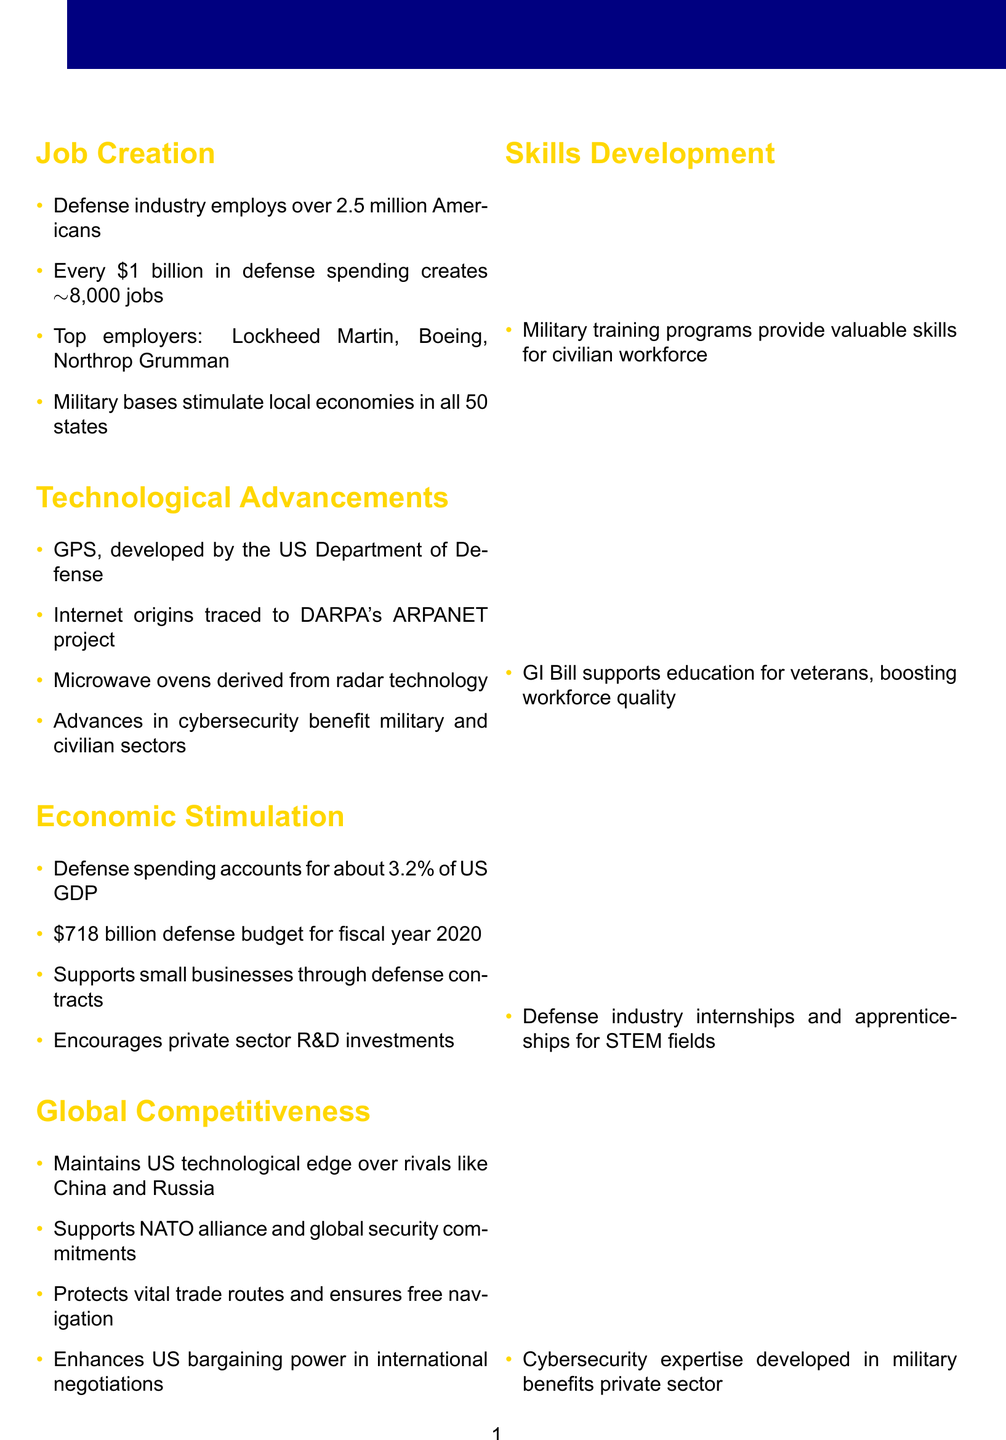What is the title of the brochure? The title of the brochure is stated at the top of the document.
Answer: Economic Benefits of Increased Military Spending How many jobs does every billion dollars in defense spending create? The document specifies that for every billion spent, a certain number of jobs are created.
Answer: Approximately 8,000 jobs What is the US defense budget for fiscal year 2020? The budget figure is provided under the Economic Stimulation section.
Answer: $718 billion What percentage of the US GDP is accounted for by defense spending? The document mentions this percentage in the Economic Stimulation section.
Answer: 3.2% Which company is listed as a top defense employer? The document provides a few companies known for defense employment.
Answer: Lockheed Martin What technological advancement was developed by the US Department of Defense? The document gives an example of a technology that originated from defense projects.
Answer: GPS How many Americans are employed in the defense industry? This figure is mentioned in the Job Creation section.
Answer: Over 2.5 million What does the GI Bill support? The document explains the benefits provided by the GI Bill.
Answer: Education for veterans What does increased military spending enhance according to the brochure? The Global Competitiveness section indicates the impact of military spending.
Answer: US bargaining power in international negotiations 